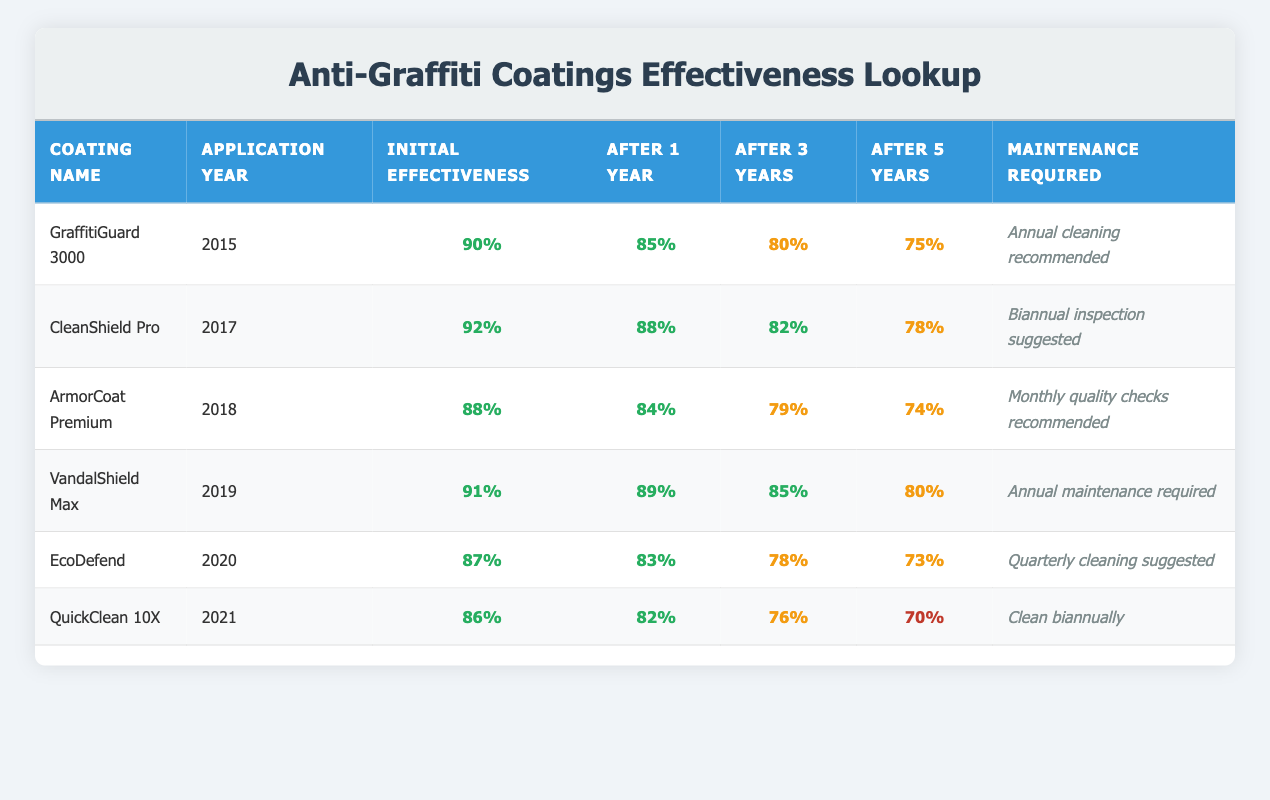What is the Initial Effectiveness Rating of CleanShield Pro? The Initial Effectiveness Rating of CleanShield Pro is directly included in the table, under the corresponding column. It is listed as 92%.
Answer: 92% What maintenance is required for EcoDefend? The table specifies the maintenance required for EcoDefend in the last column. It states that quarterly cleaning is suggested.
Answer: Quarterly cleaning suggested Which coating had the highest Initial Effectiveness Rating? Reviewing the Initial Effectiveness Ratings in the table, CleanShield Pro has the highest rating at 92%.
Answer: CleanShield Pro What is the difference in Effectiveness Rating after 3 years between VandalShield Max and QuickClean 10X? The Effectiveness Rating after 3 years for VandalShield Max is 85%, while for QuickClean 10X, it is 76%. The difference can be calculated as 85 - 76 = 9.
Answer: 9 Is the Maintenance Required for ArmorCoat Premium more frequent than that for GraffitiGuard 3000? The table states that ArmorCoat Premium requires monthly quality checks, while GraffitiGuard 3000 requires annual cleaning. Monthly is more frequent than annual.
Answer: Yes Which coating had a lower Effectiveness Rating after 5 years: EcoDefend or VandalShield Max? After 5 years, EcoDefend has a rating of 73%, and VandalShield Max has a rating of 80%. Since 73% is lower than 80%, EcoDefend had the lower rating.
Answer: EcoDefend What is the average Initial Effectiveness Rating of all coatings listed? The Initial Effectiveness Ratings are 90, 92, 88, 91, 87, and 86. Adding these values gives 524, and dividing by the number of coatings (6) results in an average of 87.33, rounding to 87.3.
Answer: 87.3 Which coating showed the smallest decline in Effectiveness Rating after 1 year? By examining the Effectiveness Ratings after 1 year for all coatings, VandalShield Max showed a decline from 91% to 89%, a decrease of only 2%. Comparing this decline with others, it is the smallest.
Answer: VandalShield Max After 3 years, is the Effectiveness Rating of ArmorCoat Premium classified as high, medium, or low? The Effectiveness Rating for ArmorCoat Premium after 3 years is 79%. According to the table's classification, anything above 75% is considered medium, so 79% falls into that category.
Answer: Medium 